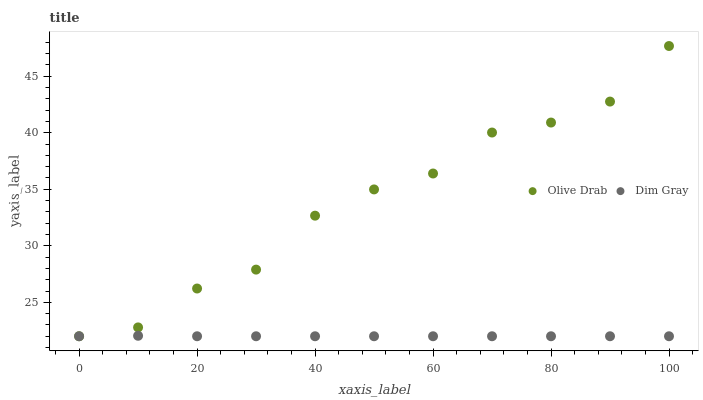Does Dim Gray have the minimum area under the curve?
Answer yes or no. Yes. Does Olive Drab have the maximum area under the curve?
Answer yes or no. Yes. Does Olive Drab have the minimum area under the curve?
Answer yes or no. No. Is Dim Gray the smoothest?
Answer yes or no. Yes. Is Olive Drab the roughest?
Answer yes or no. Yes. Is Olive Drab the smoothest?
Answer yes or no. No. Does Dim Gray have the lowest value?
Answer yes or no. Yes. Does Olive Drab have the highest value?
Answer yes or no. Yes. Does Dim Gray intersect Olive Drab?
Answer yes or no. Yes. Is Dim Gray less than Olive Drab?
Answer yes or no. No. Is Dim Gray greater than Olive Drab?
Answer yes or no. No. 